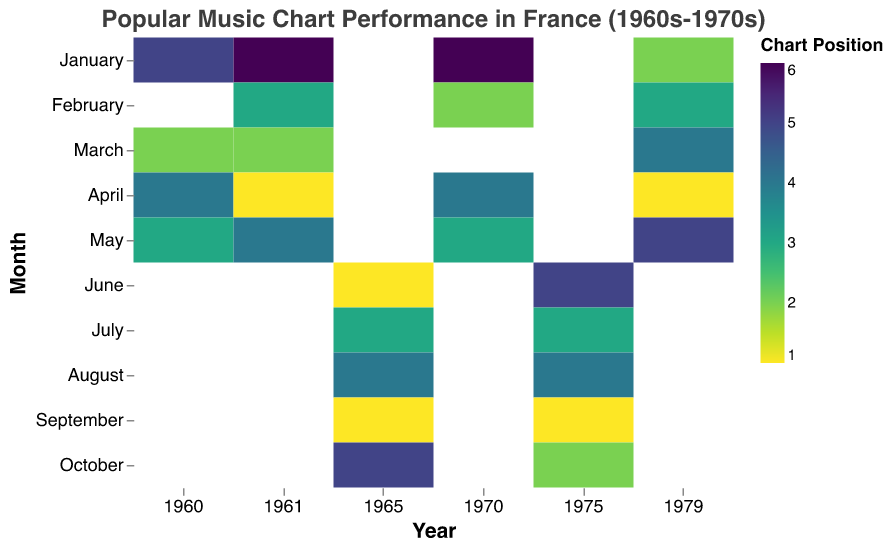What does the color represent in this heatmap? The color in the heatmap represents the chart position of a song. A specific color intensity correlates with a specific chart position on the scale shown in the legend. Darker shades typically indicate higher positions.
Answer: Chart position Which month in 1975 had the highest chart position? Find the data points for the year 1975 and look for the darkest color. September of 1975 shows the darkest shade, indicating the highest chart position.
Answer: September How many times did artists reach the number 1 chart position from 1960 to 1979? Locate all the darkest shades in the heatmap, as these represent the number 1 chart position. Count the occurrences.
Answer: 6 Which year had the best average chart position? Calculate the average chart position for each year by summing the chart positions and dividing by the number of months with data. Compare the averages to find the smallest value.
Answer: 1965 Compare the chart positions of March in 1960 and 1961. Which year had a better chart position? Look at the color intensity for March in 1960 and 1961. In 1960, the position is 2, and in 1961, it is also 2. Both years have the same chart position for March.
Answer: Same In which month and year did a song by Françoise Hardy reach number 1 chart position? Find the data points pertaining to Françoise Hardy and observe their chart positions. For example, in June of 1965, Françoise Hardy's song reached number 1.
Answer: June 1965 Which month in the 1970s had the lowest (worst) chart position? Look at the data from 1970s and find the month with the lightest shade (highest chart position number). January of 1970 shows the lightest color, representing a chart position of 6.
Answer: January 1970 How did Johnny Hallyday's chart performance in July 1965 compare to October 1975? Look at the heatmap for July 1965 and October 1975 for Johnny Hallyday. In July 1965, the chart position is 3, and in October 1975, it is 2.
Answer: October 1975 was better What is the average chart position of songs in the month of April during the entire dataset? Sum the chart positions for April across all years (1960, 1961, 1970, 1979) and divide by the number of Aprils. The sum is (4+1+4+1) = 10; dividing by 4 gives an average of 2.5.
Answer: 2.5 Which artist appears most frequently in the heatmap data? Count the occurrences of each artist's name in the dataset. Johnny Hallyday appears most frequently with a total of three entries.
Answer: Johnny Hallyday 